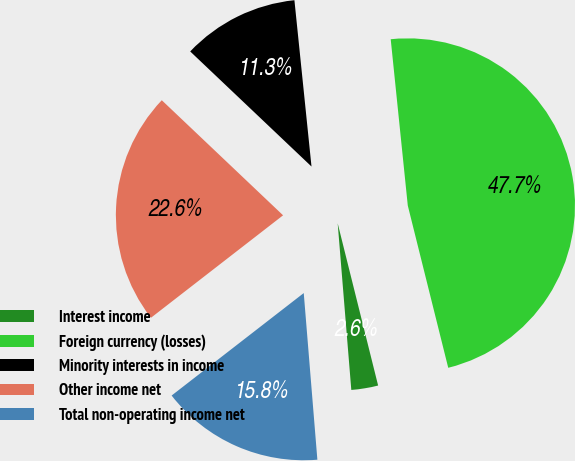Convert chart. <chart><loc_0><loc_0><loc_500><loc_500><pie_chart><fcel>Interest income<fcel>Foreign currency (losses)<fcel>Minority interests in income<fcel>Other income net<fcel>Total non-operating income net<nl><fcel>2.59%<fcel>47.74%<fcel>11.29%<fcel>22.58%<fcel>15.8%<nl></chart> 